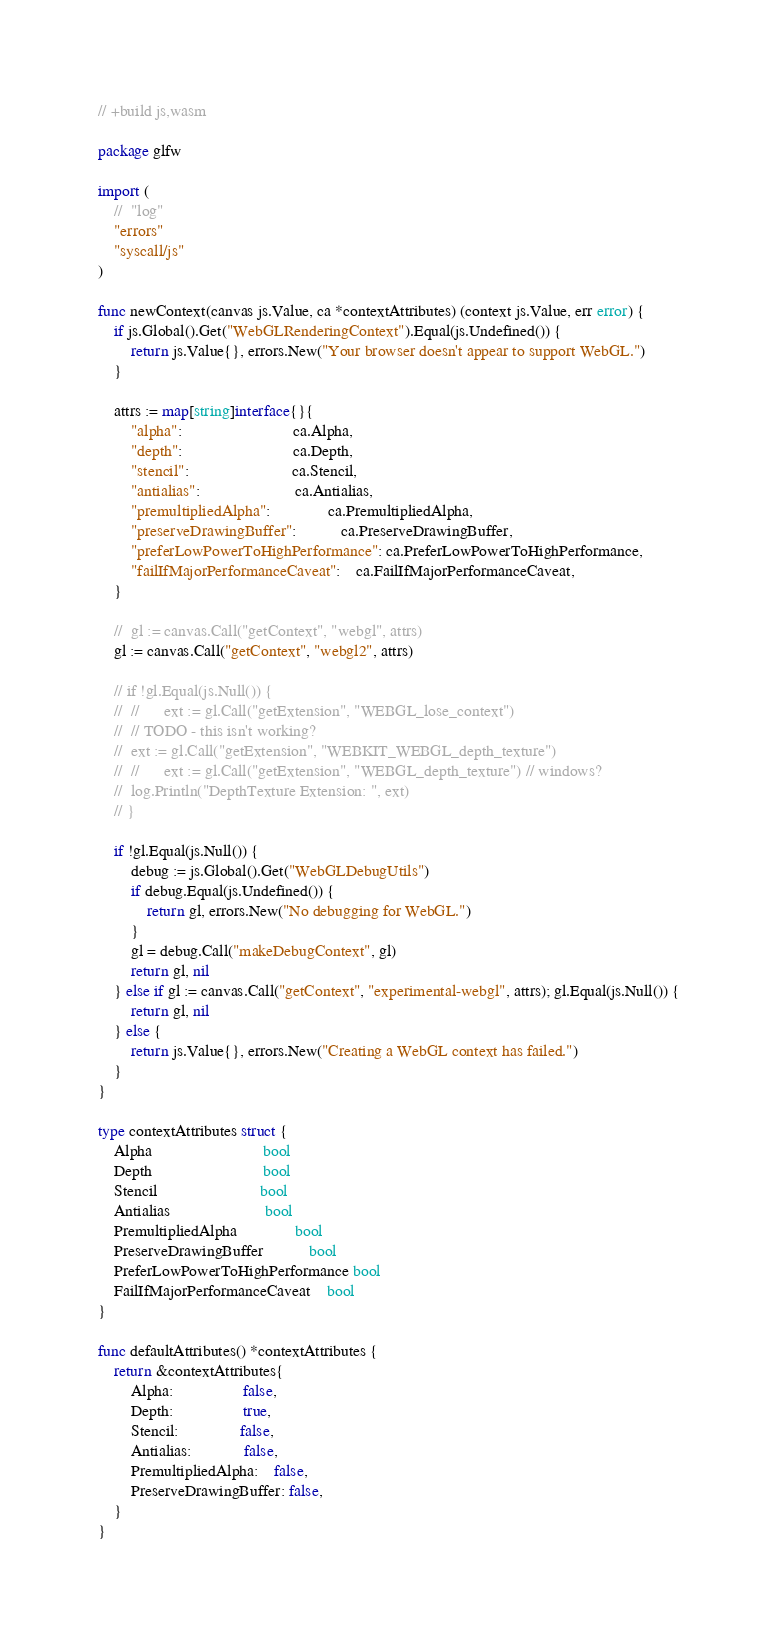<code> <loc_0><loc_0><loc_500><loc_500><_Go_>// +build js,wasm

package glfw

import (
	//	"log"
	"errors"
	"syscall/js"
)

func newContext(canvas js.Value, ca *contextAttributes) (context js.Value, err error) {
	if js.Global().Get("WebGLRenderingContext").Equal(js.Undefined()) {
		return js.Value{}, errors.New("Your browser doesn't appear to support WebGL.")
	}

	attrs := map[string]interface{}{
		"alpha":                           ca.Alpha,
		"depth":                           ca.Depth,
		"stencil":                         ca.Stencil,
		"antialias":                       ca.Antialias,
		"premultipliedAlpha":              ca.PremultipliedAlpha,
		"preserveDrawingBuffer":           ca.PreserveDrawingBuffer,
		"preferLowPowerToHighPerformance": ca.PreferLowPowerToHighPerformance,
		"failIfMajorPerformanceCaveat":    ca.FailIfMajorPerformanceCaveat,
	}

	//	gl := canvas.Call("getContext", "webgl", attrs)
	gl := canvas.Call("getContext", "webgl2", attrs)

	// if !gl.Equal(js.Null()) {
	// 	//		ext := gl.Call("getExtension", "WEBGL_lose_context")
	// 	// TODO - this isn't working?
	// 	ext := gl.Call("getExtension", "WEBKIT_WEBGL_depth_texture")
	// 	//		ext := gl.Call("getExtension", "WEBGL_depth_texture") // windows?
	// 	log.Println("DepthTexture Extension: ", ext)
	// }

	if !gl.Equal(js.Null()) {
		debug := js.Global().Get("WebGLDebugUtils")
		if debug.Equal(js.Undefined()) {
			return gl, errors.New("No debugging for WebGL.")
		}
		gl = debug.Call("makeDebugContext", gl)
		return gl, nil
	} else if gl := canvas.Call("getContext", "experimental-webgl", attrs); gl.Equal(js.Null()) {
		return gl, nil
	} else {
		return js.Value{}, errors.New("Creating a WebGL context has failed.")
	}
}

type contextAttributes struct {
	Alpha                           bool
	Depth                           bool
	Stencil                         bool
	Antialias                       bool
	PremultipliedAlpha              bool
	PreserveDrawingBuffer           bool
	PreferLowPowerToHighPerformance bool
	FailIfMajorPerformanceCaveat    bool
}

func defaultAttributes() *contextAttributes {
	return &contextAttributes{
		Alpha:                 false,
		Depth:                 true,
		Stencil:               false,
		Antialias:             false,
		PremultipliedAlpha:    false,
		PreserveDrawingBuffer: false,
	}
}
</code> 